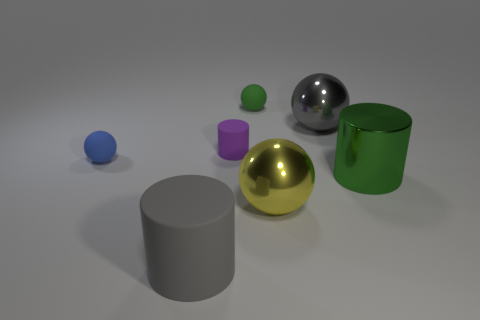Subtract all blue rubber balls. How many balls are left? 3 Add 2 small rubber things. How many objects exist? 9 Subtract all balls. How many objects are left? 3 Subtract all purple cylinders. How many cylinders are left? 2 Subtract 2 balls. How many balls are left? 2 Subtract all brown balls. Subtract all gray blocks. How many balls are left? 4 Subtract all purple cubes. How many cyan cylinders are left? 0 Subtract all tiny red matte cubes. Subtract all small blue objects. How many objects are left? 6 Add 4 tiny green matte balls. How many tiny green matte balls are left? 5 Add 1 small purple cylinders. How many small purple cylinders exist? 2 